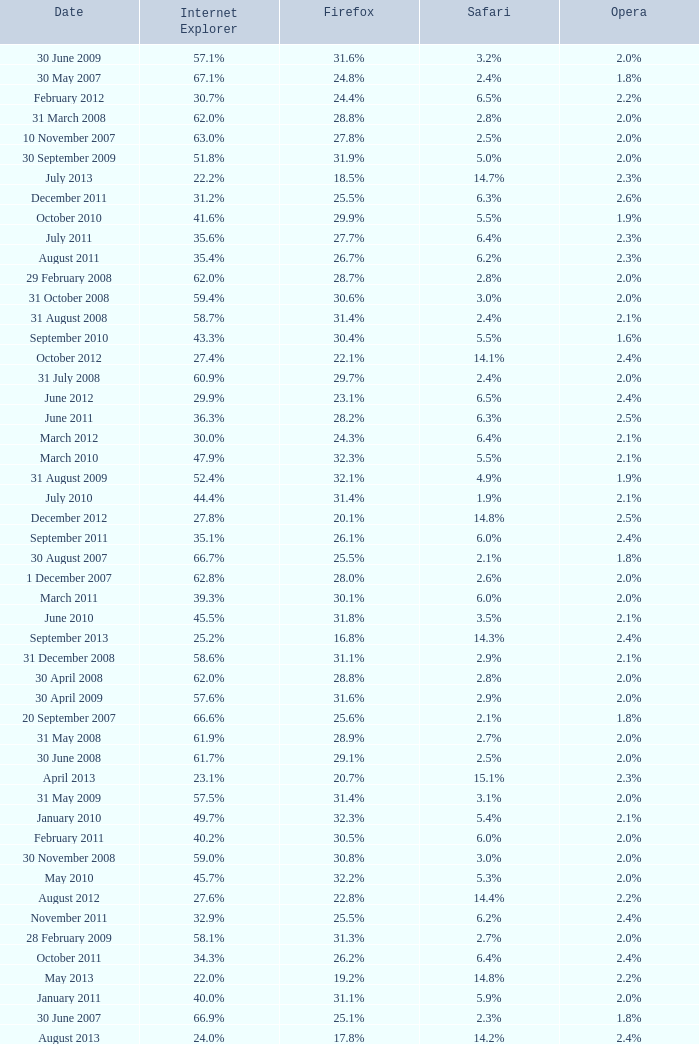What is the safari value with a 2.4% opera and 29.9% internet explorer? 6.5%. 